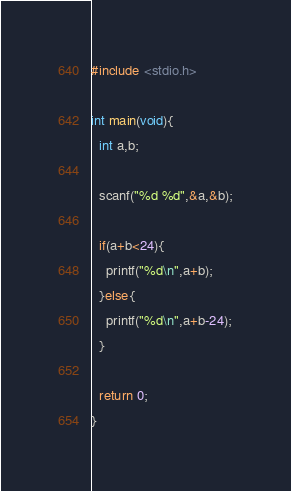<code> <loc_0><loc_0><loc_500><loc_500><_C_>#include <stdio.h>

int main(void){
  int a,b;

  scanf("%d %d",&a,&b);

  if(a+b<24){
    printf("%d\n",a+b);
  }else{
    printf("%d\n",a+b-24);
  }

  return 0;
}
</code> 